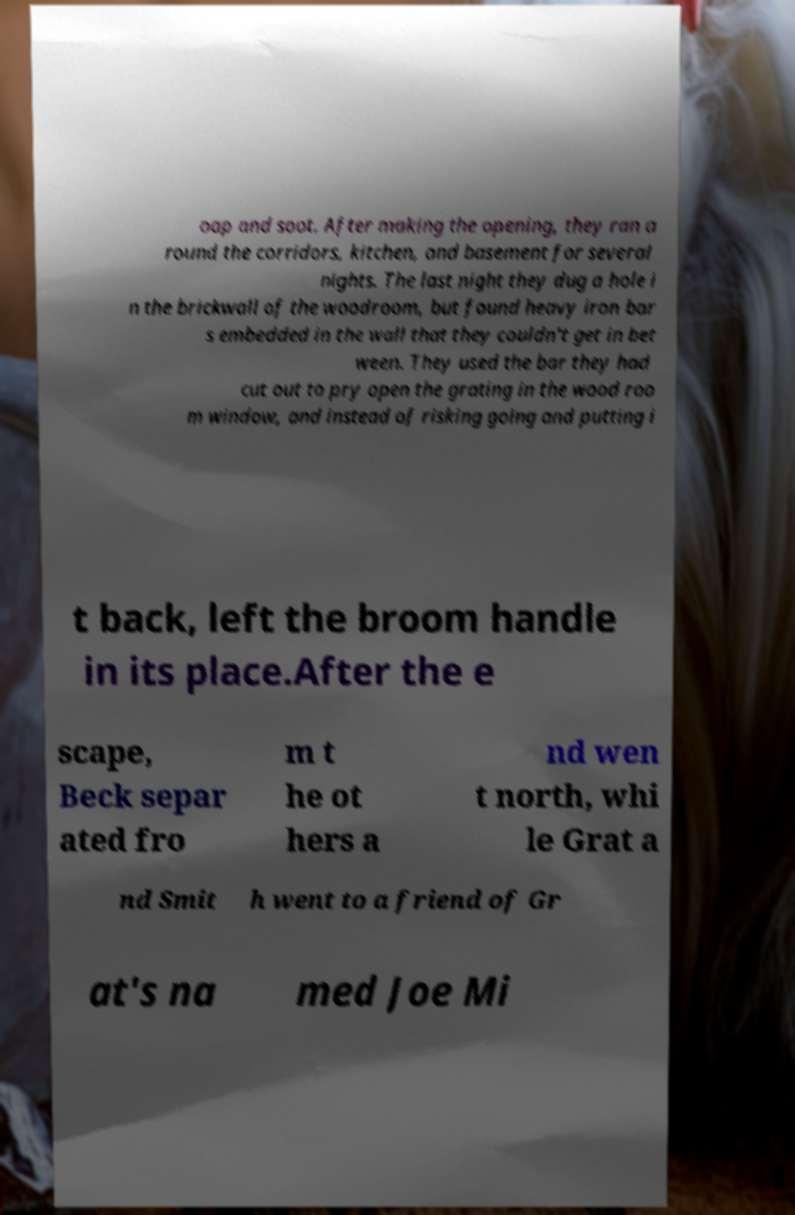Can you read and provide the text displayed in the image?This photo seems to have some interesting text. Can you extract and type it out for me? oap and soot. After making the opening, they ran a round the corridors, kitchen, and basement for several nights. The last night they dug a hole i n the brickwall of the woodroom, but found heavy iron bar s embedded in the wall that they couldn't get in bet ween. They used the bar they had cut out to pry open the grating in the wood roo m window, and instead of risking going and putting i t back, left the broom handle in its place.After the e scape, Beck separ ated fro m t he ot hers a nd wen t north, whi le Grat a nd Smit h went to a friend of Gr at's na med Joe Mi 